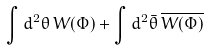Convert formula to latex. <formula><loc_0><loc_0><loc_500><loc_500>\int d ^ { 2 } \theta \, W ( \Phi ) + \int d ^ { 2 } \bar { \theta } \, \overline { W ( \Phi ) }</formula> 